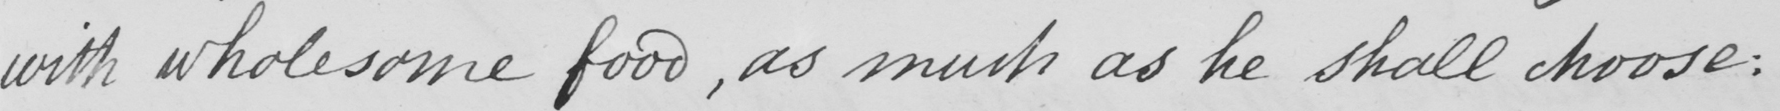Please provide the text content of this handwritten line. with wholesome food, as much as he shall choose: 